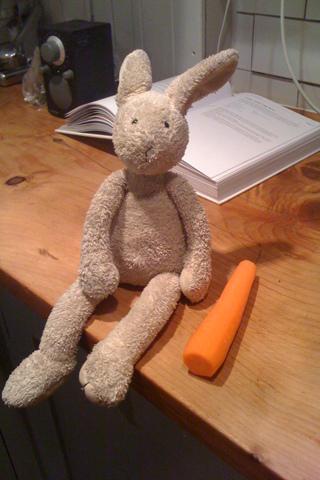How many people are wearing glasses?
Give a very brief answer. 0. 